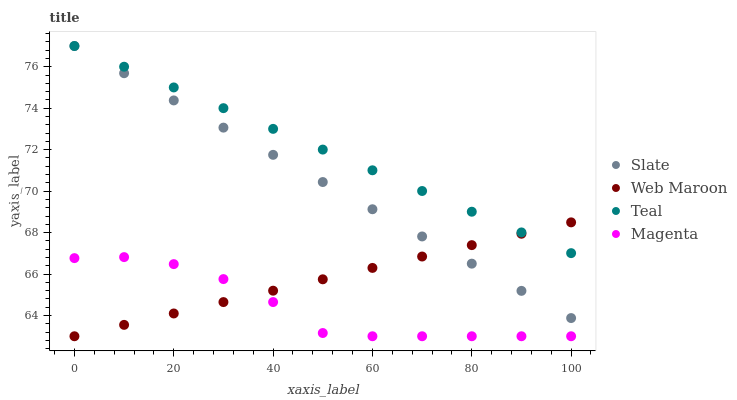Does Magenta have the minimum area under the curve?
Answer yes or no. Yes. Does Teal have the maximum area under the curve?
Answer yes or no. Yes. Does Web Maroon have the minimum area under the curve?
Answer yes or no. No. Does Web Maroon have the maximum area under the curve?
Answer yes or no. No. Is Slate the smoothest?
Answer yes or no. Yes. Is Magenta the roughest?
Answer yes or no. Yes. Is Web Maroon the smoothest?
Answer yes or no. No. Is Web Maroon the roughest?
Answer yes or no. No. Does Web Maroon have the lowest value?
Answer yes or no. Yes. Does Teal have the lowest value?
Answer yes or no. No. Does Teal have the highest value?
Answer yes or no. Yes. Does Web Maroon have the highest value?
Answer yes or no. No. Is Magenta less than Teal?
Answer yes or no. Yes. Is Slate greater than Magenta?
Answer yes or no. Yes. Does Teal intersect Slate?
Answer yes or no. Yes. Is Teal less than Slate?
Answer yes or no. No. Is Teal greater than Slate?
Answer yes or no. No. Does Magenta intersect Teal?
Answer yes or no. No. 